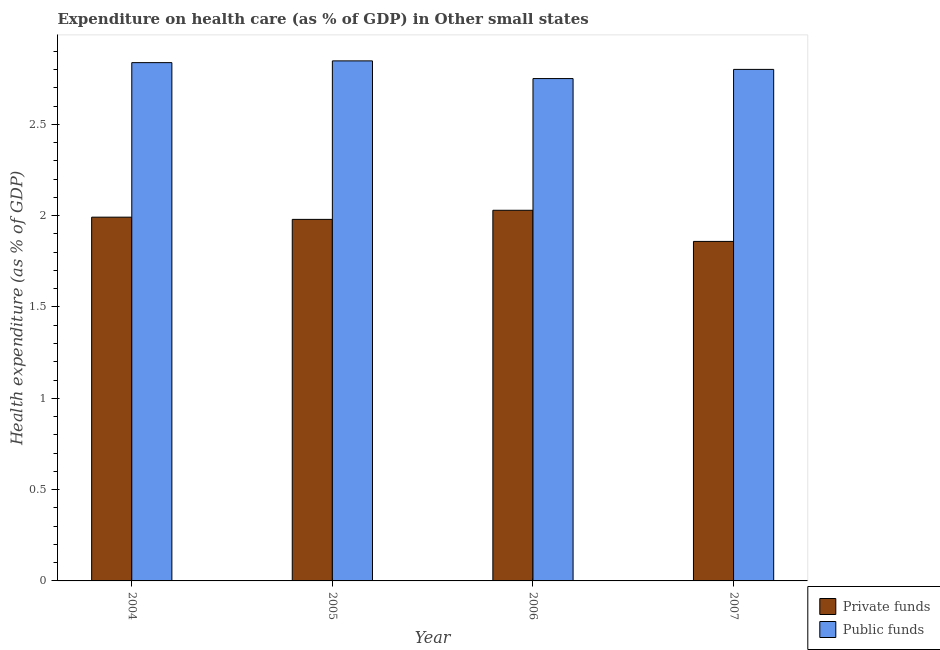How many groups of bars are there?
Ensure brevity in your answer.  4. How many bars are there on the 4th tick from the left?
Your answer should be very brief. 2. How many bars are there on the 4th tick from the right?
Keep it short and to the point. 2. What is the label of the 2nd group of bars from the left?
Offer a very short reply. 2005. What is the amount of private funds spent in healthcare in 2005?
Provide a short and direct response. 1.98. Across all years, what is the maximum amount of private funds spent in healthcare?
Your response must be concise. 2.03. Across all years, what is the minimum amount of private funds spent in healthcare?
Ensure brevity in your answer.  1.86. In which year was the amount of public funds spent in healthcare maximum?
Keep it short and to the point. 2005. In which year was the amount of public funds spent in healthcare minimum?
Your answer should be very brief. 2006. What is the total amount of private funds spent in healthcare in the graph?
Provide a short and direct response. 7.86. What is the difference between the amount of private funds spent in healthcare in 2004 and that in 2007?
Your response must be concise. 0.13. What is the difference between the amount of private funds spent in healthcare in 2006 and the amount of public funds spent in healthcare in 2004?
Ensure brevity in your answer.  0.04. What is the average amount of private funds spent in healthcare per year?
Keep it short and to the point. 1.96. In the year 2006, what is the difference between the amount of private funds spent in healthcare and amount of public funds spent in healthcare?
Provide a succinct answer. 0. In how many years, is the amount of private funds spent in healthcare greater than 1.5 %?
Keep it short and to the point. 4. What is the ratio of the amount of public funds spent in healthcare in 2006 to that in 2007?
Offer a very short reply. 0.98. Is the amount of public funds spent in healthcare in 2005 less than that in 2007?
Provide a succinct answer. No. What is the difference between the highest and the second highest amount of private funds spent in healthcare?
Offer a terse response. 0.04. What is the difference between the highest and the lowest amount of private funds spent in healthcare?
Offer a terse response. 0.17. In how many years, is the amount of public funds spent in healthcare greater than the average amount of public funds spent in healthcare taken over all years?
Make the answer very short. 2. Is the sum of the amount of public funds spent in healthcare in 2005 and 2006 greater than the maximum amount of private funds spent in healthcare across all years?
Ensure brevity in your answer.  Yes. What does the 1st bar from the left in 2004 represents?
Ensure brevity in your answer.  Private funds. What does the 2nd bar from the right in 2004 represents?
Ensure brevity in your answer.  Private funds. Are the values on the major ticks of Y-axis written in scientific E-notation?
Ensure brevity in your answer.  No. Does the graph contain any zero values?
Your answer should be compact. No. Does the graph contain grids?
Your answer should be compact. No. How many legend labels are there?
Provide a succinct answer. 2. What is the title of the graph?
Ensure brevity in your answer.  Expenditure on health care (as % of GDP) in Other small states. What is the label or title of the X-axis?
Offer a terse response. Year. What is the label or title of the Y-axis?
Ensure brevity in your answer.  Health expenditure (as % of GDP). What is the Health expenditure (as % of GDP) of Private funds in 2004?
Ensure brevity in your answer.  1.99. What is the Health expenditure (as % of GDP) of Public funds in 2004?
Keep it short and to the point. 2.84. What is the Health expenditure (as % of GDP) of Private funds in 2005?
Provide a succinct answer. 1.98. What is the Health expenditure (as % of GDP) of Public funds in 2005?
Make the answer very short. 2.85. What is the Health expenditure (as % of GDP) of Private funds in 2006?
Offer a very short reply. 2.03. What is the Health expenditure (as % of GDP) of Public funds in 2006?
Give a very brief answer. 2.75. What is the Health expenditure (as % of GDP) of Private funds in 2007?
Ensure brevity in your answer.  1.86. What is the Health expenditure (as % of GDP) in Public funds in 2007?
Your answer should be very brief. 2.8. Across all years, what is the maximum Health expenditure (as % of GDP) in Private funds?
Provide a short and direct response. 2.03. Across all years, what is the maximum Health expenditure (as % of GDP) of Public funds?
Give a very brief answer. 2.85. Across all years, what is the minimum Health expenditure (as % of GDP) of Private funds?
Your response must be concise. 1.86. Across all years, what is the minimum Health expenditure (as % of GDP) in Public funds?
Provide a short and direct response. 2.75. What is the total Health expenditure (as % of GDP) in Private funds in the graph?
Offer a terse response. 7.86. What is the total Health expenditure (as % of GDP) of Public funds in the graph?
Keep it short and to the point. 11.24. What is the difference between the Health expenditure (as % of GDP) in Private funds in 2004 and that in 2005?
Keep it short and to the point. 0.01. What is the difference between the Health expenditure (as % of GDP) of Public funds in 2004 and that in 2005?
Provide a succinct answer. -0.01. What is the difference between the Health expenditure (as % of GDP) of Private funds in 2004 and that in 2006?
Keep it short and to the point. -0.04. What is the difference between the Health expenditure (as % of GDP) in Public funds in 2004 and that in 2006?
Make the answer very short. 0.09. What is the difference between the Health expenditure (as % of GDP) in Private funds in 2004 and that in 2007?
Your answer should be very brief. 0.13. What is the difference between the Health expenditure (as % of GDP) in Public funds in 2004 and that in 2007?
Give a very brief answer. 0.04. What is the difference between the Health expenditure (as % of GDP) in Private funds in 2005 and that in 2006?
Provide a succinct answer. -0.05. What is the difference between the Health expenditure (as % of GDP) in Public funds in 2005 and that in 2006?
Your answer should be very brief. 0.1. What is the difference between the Health expenditure (as % of GDP) of Private funds in 2005 and that in 2007?
Your answer should be compact. 0.12. What is the difference between the Health expenditure (as % of GDP) in Public funds in 2005 and that in 2007?
Ensure brevity in your answer.  0.05. What is the difference between the Health expenditure (as % of GDP) of Private funds in 2006 and that in 2007?
Make the answer very short. 0.17. What is the difference between the Health expenditure (as % of GDP) in Public funds in 2006 and that in 2007?
Offer a very short reply. -0.05. What is the difference between the Health expenditure (as % of GDP) of Private funds in 2004 and the Health expenditure (as % of GDP) of Public funds in 2005?
Make the answer very short. -0.86. What is the difference between the Health expenditure (as % of GDP) in Private funds in 2004 and the Health expenditure (as % of GDP) in Public funds in 2006?
Your answer should be compact. -0.76. What is the difference between the Health expenditure (as % of GDP) of Private funds in 2004 and the Health expenditure (as % of GDP) of Public funds in 2007?
Give a very brief answer. -0.81. What is the difference between the Health expenditure (as % of GDP) in Private funds in 2005 and the Health expenditure (as % of GDP) in Public funds in 2006?
Make the answer very short. -0.77. What is the difference between the Health expenditure (as % of GDP) in Private funds in 2005 and the Health expenditure (as % of GDP) in Public funds in 2007?
Offer a terse response. -0.82. What is the difference between the Health expenditure (as % of GDP) of Private funds in 2006 and the Health expenditure (as % of GDP) of Public funds in 2007?
Your answer should be compact. -0.77. What is the average Health expenditure (as % of GDP) in Private funds per year?
Your answer should be compact. 1.96. What is the average Health expenditure (as % of GDP) in Public funds per year?
Ensure brevity in your answer.  2.81. In the year 2004, what is the difference between the Health expenditure (as % of GDP) of Private funds and Health expenditure (as % of GDP) of Public funds?
Your answer should be very brief. -0.85. In the year 2005, what is the difference between the Health expenditure (as % of GDP) in Private funds and Health expenditure (as % of GDP) in Public funds?
Ensure brevity in your answer.  -0.87. In the year 2006, what is the difference between the Health expenditure (as % of GDP) in Private funds and Health expenditure (as % of GDP) in Public funds?
Give a very brief answer. -0.72. In the year 2007, what is the difference between the Health expenditure (as % of GDP) in Private funds and Health expenditure (as % of GDP) in Public funds?
Keep it short and to the point. -0.94. What is the ratio of the Health expenditure (as % of GDP) in Public funds in 2004 to that in 2005?
Offer a terse response. 1. What is the ratio of the Health expenditure (as % of GDP) of Private funds in 2004 to that in 2006?
Provide a succinct answer. 0.98. What is the ratio of the Health expenditure (as % of GDP) of Public funds in 2004 to that in 2006?
Your answer should be compact. 1.03. What is the ratio of the Health expenditure (as % of GDP) in Private funds in 2004 to that in 2007?
Your answer should be very brief. 1.07. What is the ratio of the Health expenditure (as % of GDP) of Public funds in 2004 to that in 2007?
Your answer should be compact. 1.01. What is the ratio of the Health expenditure (as % of GDP) in Private funds in 2005 to that in 2006?
Give a very brief answer. 0.98. What is the ratio of the Health expenditure (as % of GDP) in Public funds in 2005 to that in 2006?
Give a very brief answer. 1.04. What is the ratio of the Health expenditure (as % of GDP) of Private funds in 2005 to that in 2007?
Your response must be concise. 1.06. What is the ratio of the Health expenditure (as % of GDP) in Public funds in 2005 to that in 2007?
Offer a very short reply. 1.02. What is the ratio of the Health expenditure (as % of GDP) of Private funds in 2006 to that in 2007?
Your answer should be compact. 1.09. What is the ratio of the Health expenditure (as % of GDP) in Public funds in 2006 to that in 2007?
Provide a short and direct response. 0.98. What is the difference between the highest and the second highest Health expenditure (as % of GDP) of Private funds?
Your response must be concise. 0.04. What is the difference between the highest and the second highest Health expenditure (as % of GDP) of Public funds?
Your answer should be compact. 0.01. What is the difference between the highest and the lowest Health expenditure (as % of GDP) in Private funds?
Your response must be concise. 0.17. What is the difference between the highest and the lowest Health expenditure (as % of GDP) of Public funds?
Offer a very short reply. 0.1. 